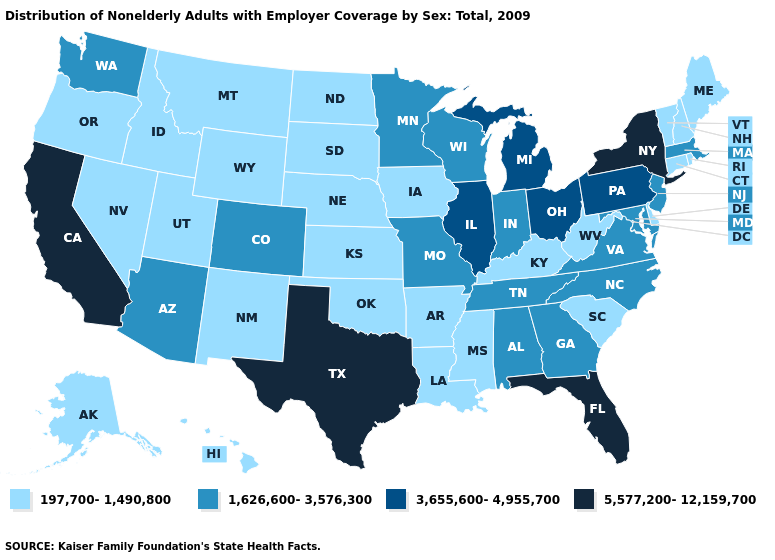Does North Dakota have the same value as Rhode Island?
Quick response, please. Yes. Name the states that have a value in the range 197,700-1,490,800?
Write a very short answer. Alaska, Arkansas, Connecticut, Delaware, Hawaii, Idaho, Iowa, Kansas, Kentucky, Louisiana, Maine, Mississippi, Montana, Nebraska, Nevada, New Hampshire, New Mexico, North Dakota, Oklahoma, Oregon, Rhode Island, South Carolina, South Dakota, Utah, Vermont, West Virginia, Wyoming. What is the value of Vermont?
Keep it brief. 197,700-1,490,800. Is the legend a continuous bar?
Keep it brief. No. What is the lowest value in states that border Washington?
Quick response, please. 197,700-1,490,800. Which states hav the highest value in the Northeast?
Keep it brief. New York. Name the states that have a value in the range 1,626,600-3,576,300?
Concise answer only. Alabama, Arizona, Colorado, Georgia, Indiana, Maryland, Massachusetts, Minnesota, Missouri, New Jersey, North Carolina, Tennessee, Virginia, Washington, Wisconsin. Among the states that border New Hampshire , which have the highest value?
Concise answer only. Massachusetts. What is the highest value in the MidWest ?
Be succinct. 3,655,600-4,955,700. Does Wyoming have the highest value in the West?
Short answer required. No. Among the states that border California , does Oregon have the lowest value?
Give a very brief answer. Yes. Does Indiana have a higher value than West Virginia?
Be succinct. Yes. Name the states that have a value in the range 3,655,600-4,955,700?
Keep it brief. Illinois, Michigan, Ohio, Pennsylvania. Which states have the lowest value in the West?
Answer briefly. Alaska, Hawaii, Idaho, Montana, Nevada, New Mexico, Oregon, Utah, Wyoming. Which states have the lowest value in the West?
Short answer required. Alaska, Hawaii, Idaho, Montana, Nevada, New Mexico, Oregon, Utah, Wyoming. 